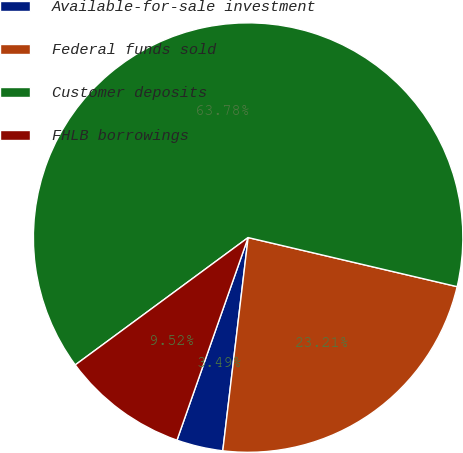Convert chart. <chart><loc_0><loc_0><loc_500><loc_500><pie_chart><fcel>Available-for-sale investment<fcel>Federal funds sold<fcel>Customer deposits<fcel>FHLB borrowings<nl><fcel>3.49%<fcel>23.21%<fcel>63.77%<fcel>9.52%<nl></chart> 